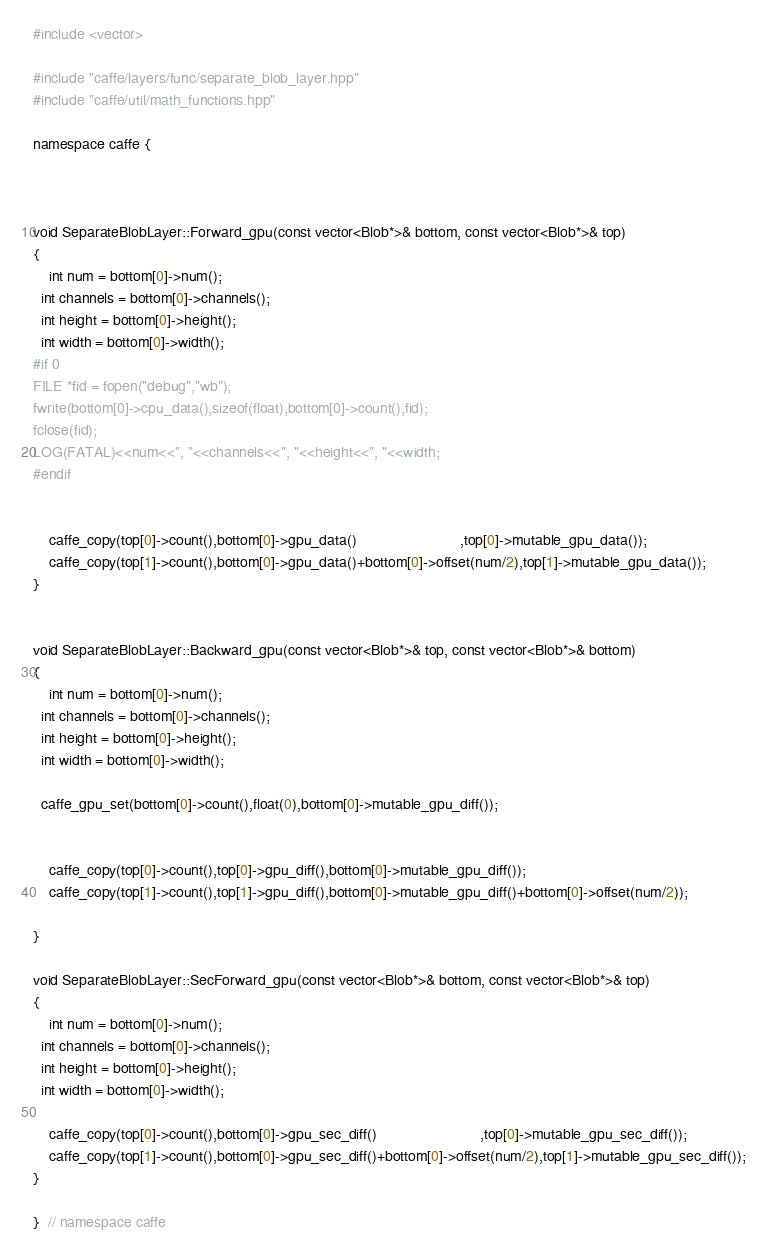<code> <loc_0><loc_0><loc_500><loc_500><_Cuda_>
#include <vector>

#include "caffe/layers/func/separate_blob_layer.hpp"
#include "caffe/util/math_functions.hpp"

namespace caffe {



void SeparateBlobLayer::Forward_gpu(const vector<Blob*>& bottom, const vector<Blob*>& top) 
{
	int num = bottom[0]->num();
  int channels = bottom[0]->channels();
  int height = bottom[0]->height();
  int width = bottom[0]->width();
#if 0
FILE *fid = fopen("debug","wb");
fwrite(bottom[0]->cpu_data(),sizeof(float),bottom[0]->count(),fid);
fclose(fid);
LOG(FATAL)<<num<<", "<<channels<<", "<<height<<", "<<width;
#endif
  
	
	caffe_copy(top[0]->count(),bottom[0]->gpu_data()                         ,top[0]->mutable_gpu_data());
	caffe_copy(top[1]->count(),bottom[0]->gpu_data()+bottom[0]->offset(num/2),top[1]->mutable_gpu_data());
}


void SeparateBlobLayer::Backward_gpu(const vector<Blob*>& top, const vector<Blob*>& bottom) 
{
	int num = bottom[0]->num();
  int channels = bottom[0]->channels();
  int height = bottom[0]->height();
  int width = bottom[0]->width();
  
  caffe_gpu_set(bottom[0]->count(),float(0),bottom[0]->mutable_gpu_diff());
  
	
	caffe_copy(top[0]->count(),top[0]->gpu_diff(),bottom[0]->mutable_gpu_diff());
	caffe_copy(top[1]->count(),top[1]->gpu_diff(),bottom[0]->mutable_gpu_diff()+bottom[0]->offset(num/2));

}

void SeparateBlobLayer::SecForward_gpu(const vector<Blob*>& bottom, const vector<Blob*>& top) 
{
	int num = bottom[0]->num();
  int channels = bottom[0]->channels();
  int height = bottom[0]->height();
  int width = bottom[0]->width();
  
	caffe_copy(top[0]->count(),bottom[0]->gpu_sec_diff()                         ,top[0]->mutable_gpu_sec_diff());
	caffe_copy(top[1]->count(),bottom[0]->gpu_sec_diff()+bottom[0]->offset(num/2),top[1]->mutable_gpu_sec_diff());
}

}  // namespace caffe
</code> 